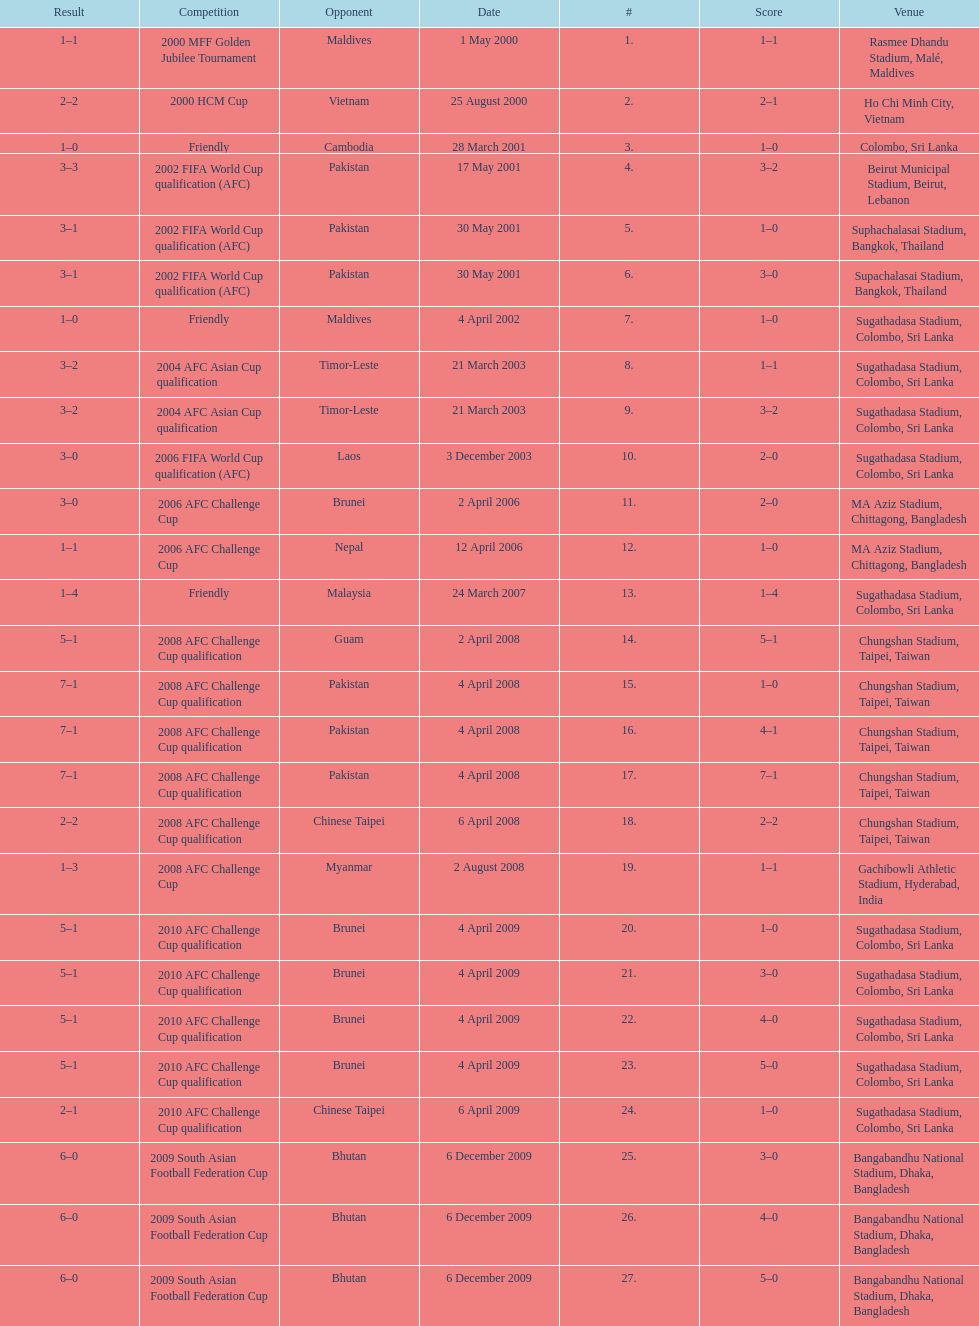In how many games did sri lanka score at least 2 goals? 16. 